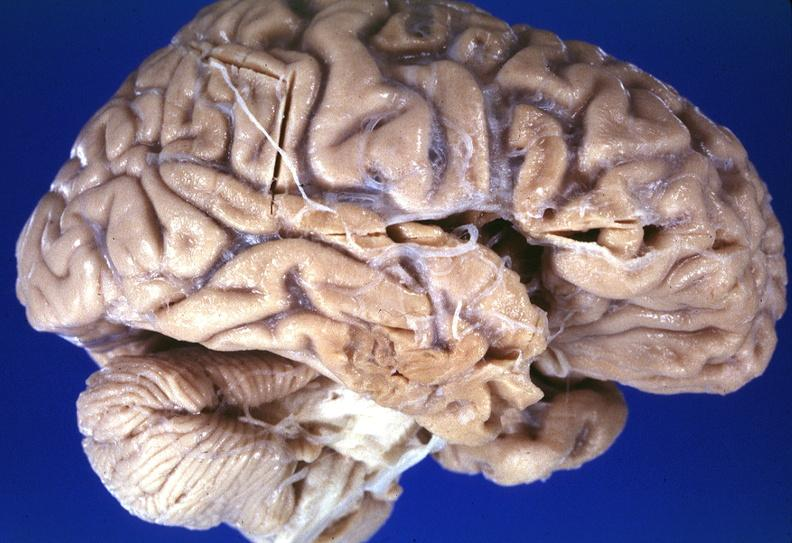does granulosa cell tumor show brain, frontal lobe atrophy, pick 's disease?
Answer the question using a single word or phrase. No 